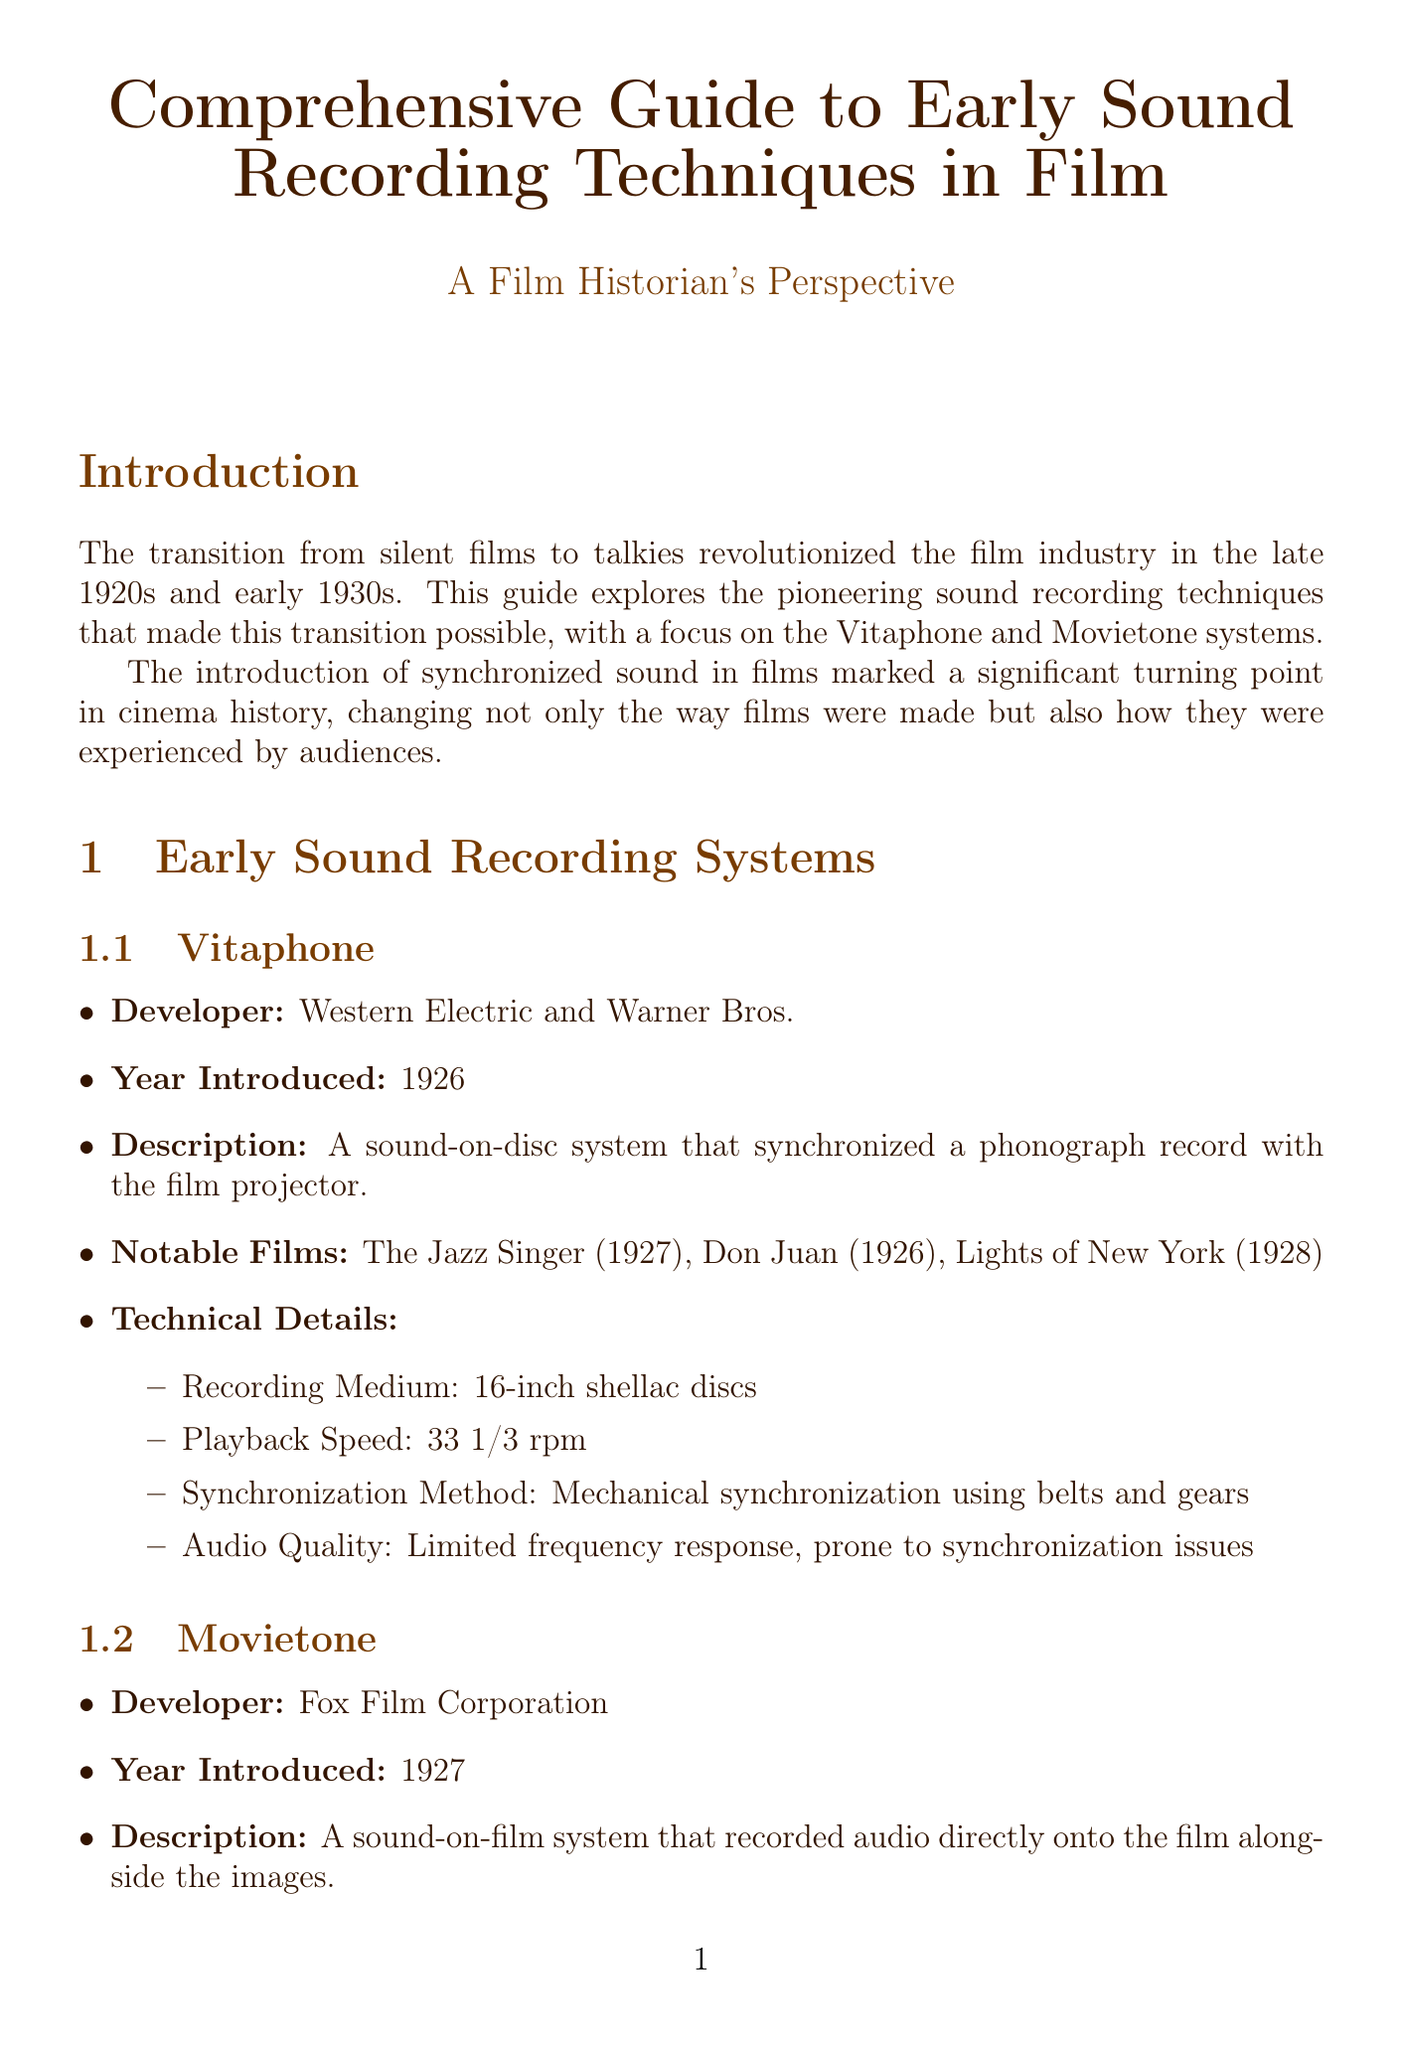What year was Vitaphone introduced? The document states that Vitaphone was introduced in the year 1926.
Answer: 1926 Who developed the Movietone system? According to the document, Movietone was developed by the Fox Film Corporation.
Answer: Fox Film Corporation What medium did Vitaphone use for recording? The document specifies that Vitaphone used 16-inch shellac discs as the recording medium.
Answer: 16-inch shellac discs What are two notable films that used the Movietone system? The document mentions "Sunrise: A Song of Two Humans" and "The Air Circus" as notable films utilizing the Movietone system.
Answer: Sunrise: A Song of Two Humans, The Air Circus How did early sound stages achieve soundproofing? The document indicates that early sound stages were heavily insulated to prevent external noise for soundproofing.
Answer: Heavily insulated What impact did the introduction of sound technology have on silent film stars? The document notes that there was a decline of silent film stars unable to transition to talkies due to the introduction of sound technology.
Answer: Decline of silent film stars Which figure innovated the Phonofilm system? The document states that Lee de Forest invented the Phonofilm system, which was a precursor to Movietone.
Answer: Lee de Forest What was a challenge in restoring early sound films? According to the document, one challenge in restoration is the degradation of early sound discs and films.
Answer: Degradation of early sound discs and films 